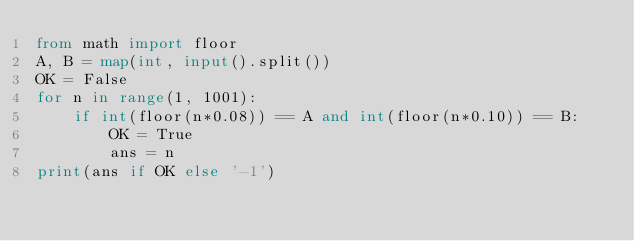Convert code to text. <code><loc_0><loc_0><loc_500><loc_500><_Python_>from math import floor
A, B = map(int, input().split())
OK = False
for n in range(1, 1001):
    if int(floor(n*0.08)) == A and int(floor(n*0.10)) == B:
        OK = True
        ans = n
print(ans if OK else '-1')</code> 